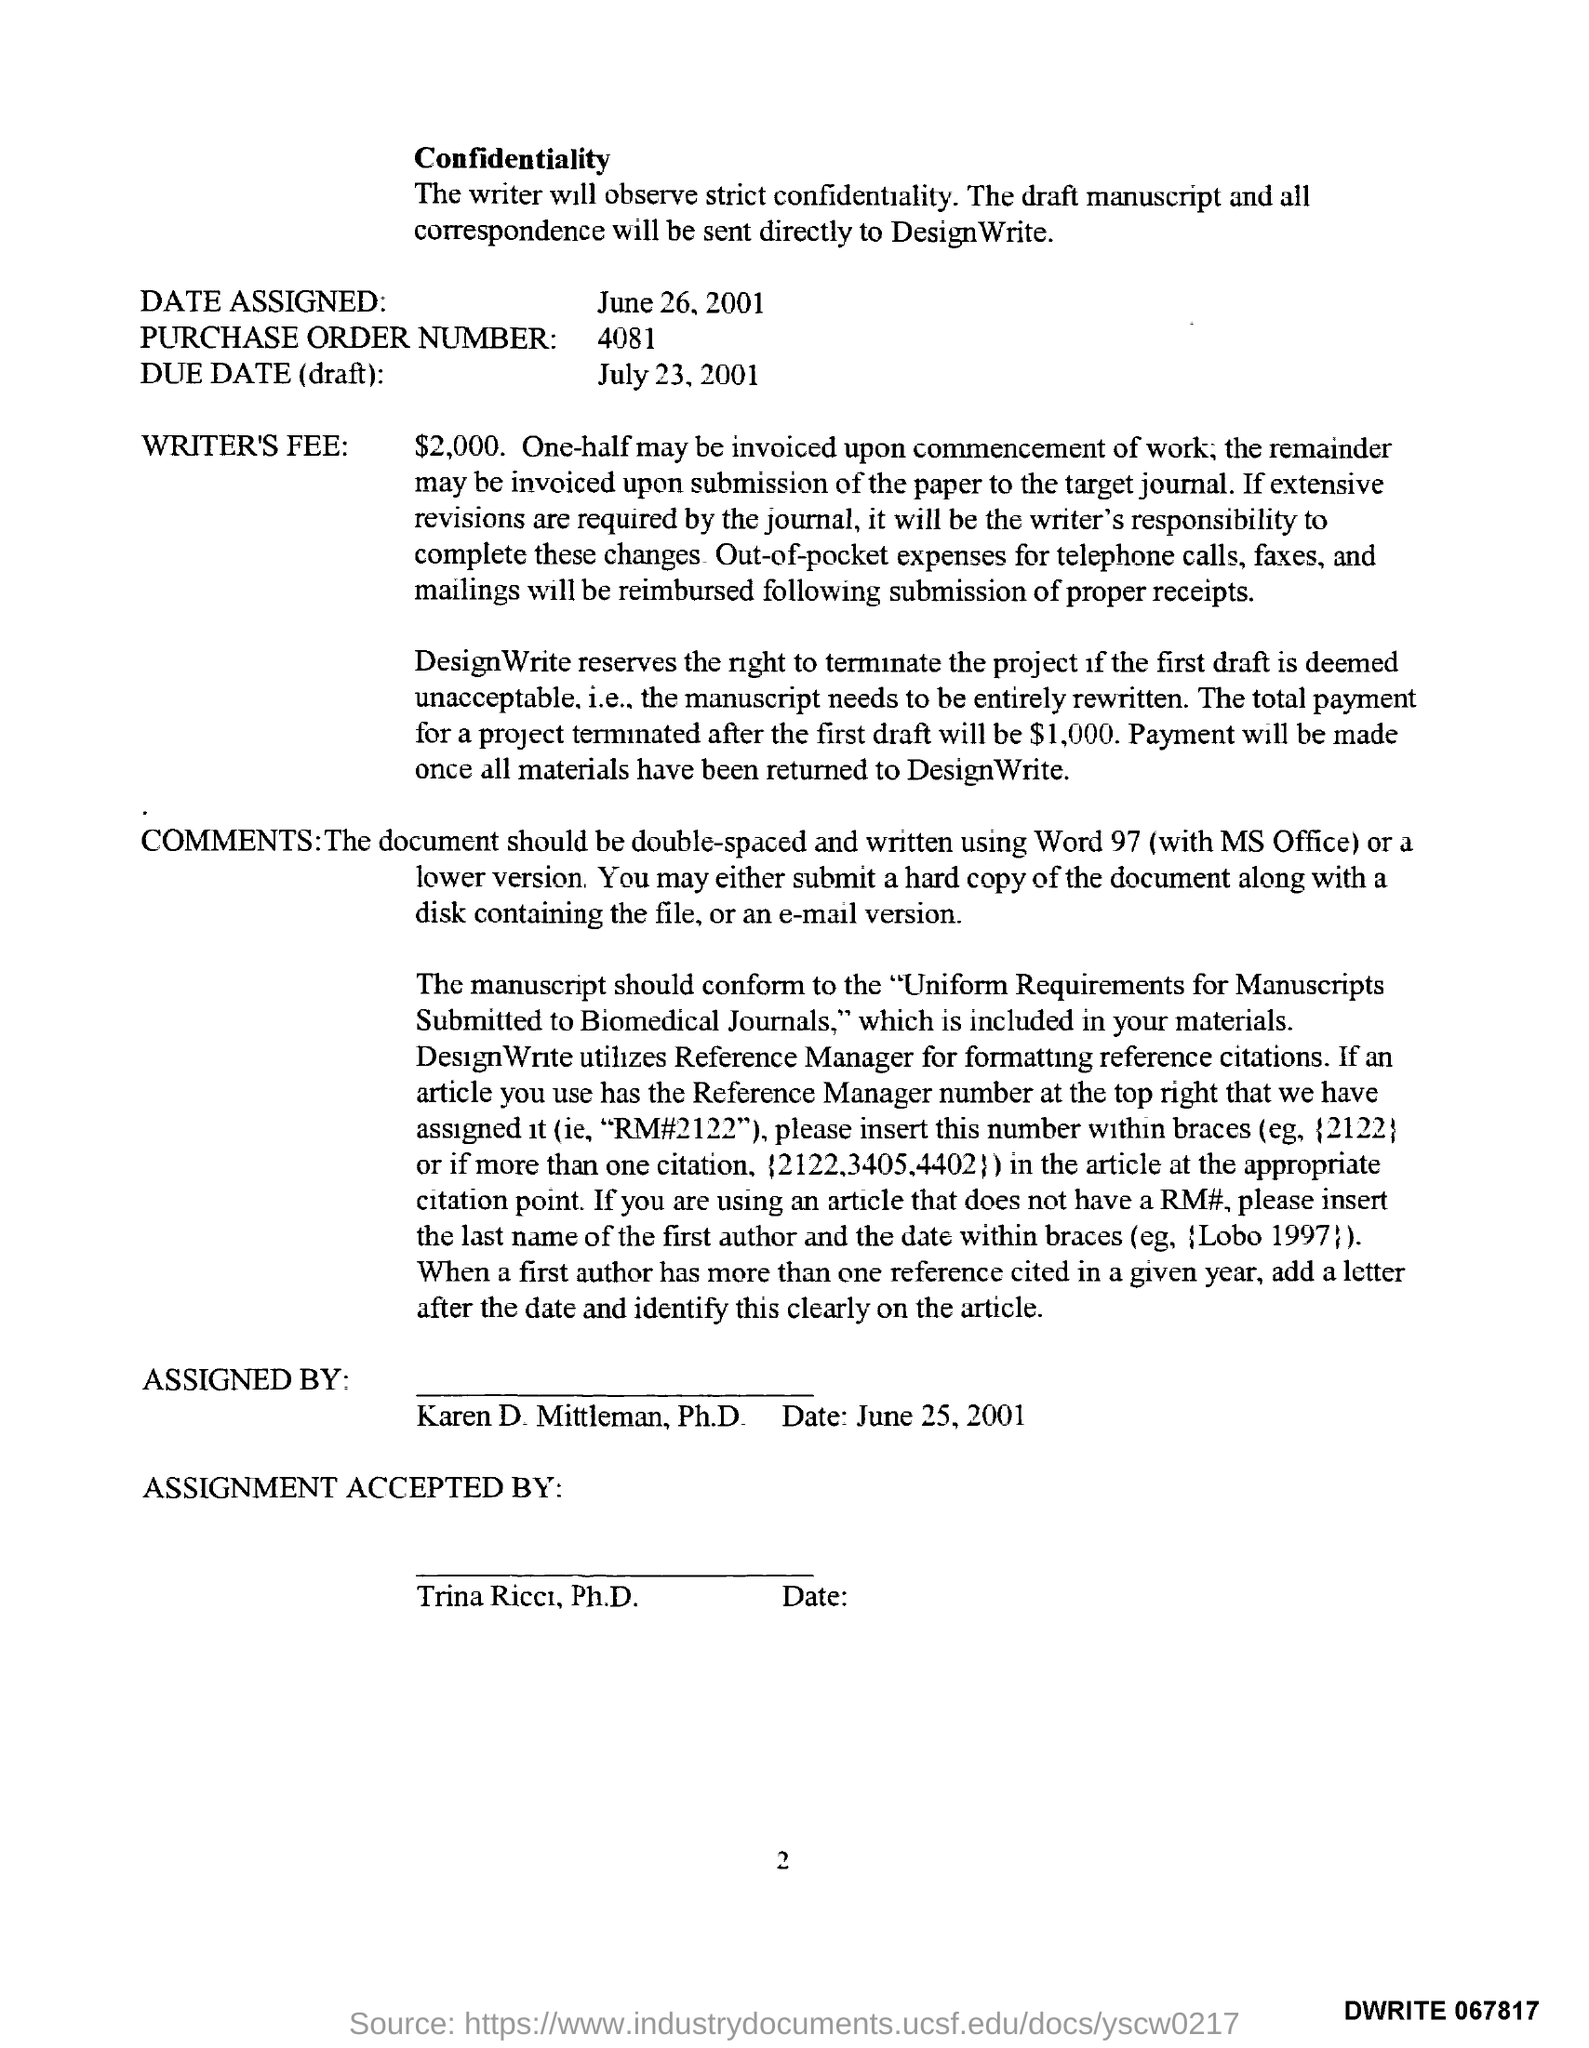What is the Date Assigned as per the document?
Make the answer very short. June 26, 2001. What is the Purchase Order Number given in the document?
Keep it short and to the point. 4081. What is the due date (draft) mentioned in the document?
Your answer should be compact. July 23,2001. What is the writer's fee mentioned in the document?
Offer a terse response. $2,000. Who has assigned this document?
Offer a very short reply. Karen D. Mittleman, Ph.D. Who has accepted the assignment?
Your answer should be very brief. Trina Ricci, Ph.D. What is the total payment for a project terminated after the first draft?
Your answer should be very brief. 1,000. 